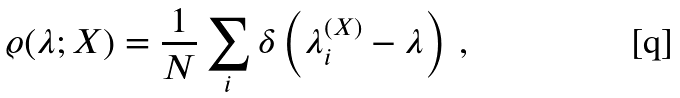<formula> <loc_0><loc_0><loc_500><loc_500>\varrho ( \lambda ; X ) = \frac { 1 } { N } \sum _ { i } \delta \left ( \lambda _ { i } ^ { ( X ) } - \lambda \right ) \, ,</formula> 